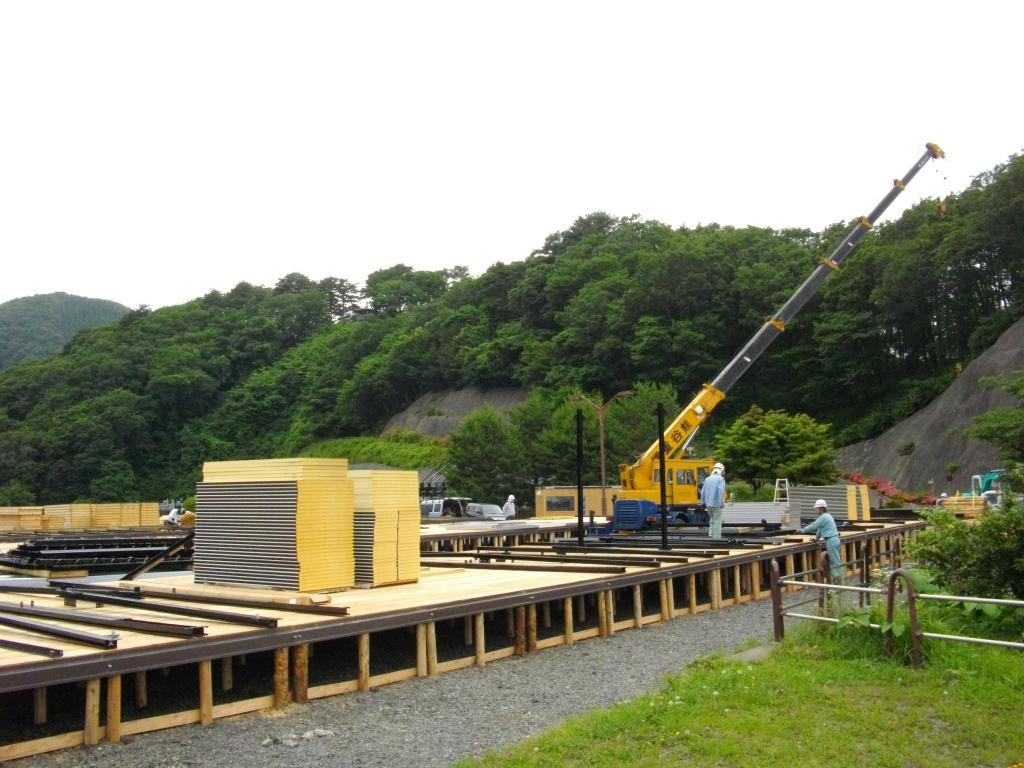What type of vehicle is present in the image? There is a mobile crane in the image. What can be seen in the background of the image? There are trees in the background of the image. What is visible at the top of the image? The sky is visible at the top of the image. Where is the sink located in the image? There is no sink present in the image. Can you see any horses in the image? There are no horses present in the image. 